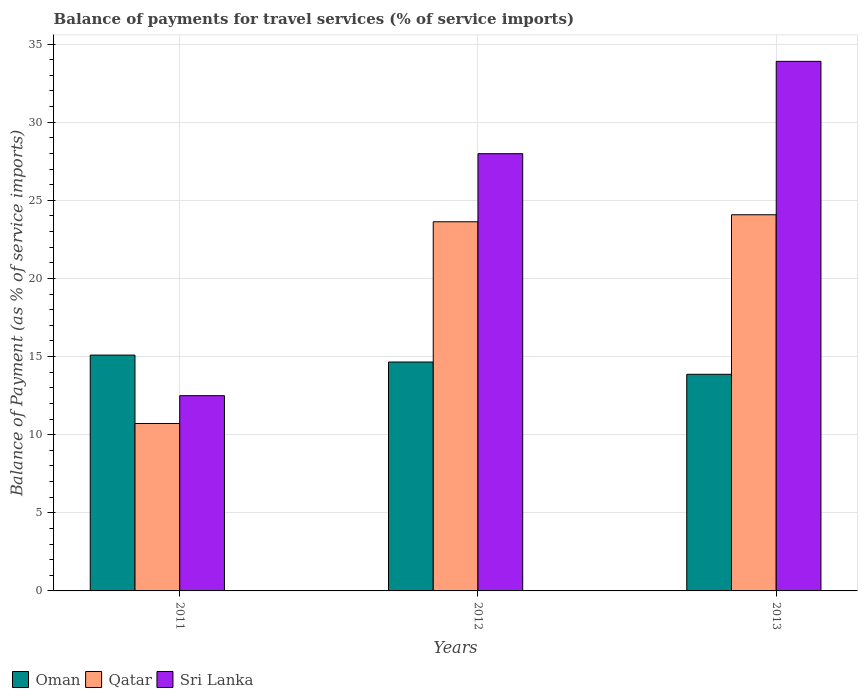How many different coloured bars are there?
Your answer should be compact. 3. How many groups of bars are there?
Your answer should be very brief. 3. Are the number of bars per tick equal to the number of legend labels?
Your answer should be very brief. Yes. Are the number of bars on each tick of the X-axis equal?
Keep it short and to the point. Yes. How many bars are there on the 3rd tick from the right?
Provide a short and direct response. 3. What is the balance of payments for travel services in Sri Lanka in 2011?
Ensure brevity in your answer.  12.5. Across all years, what is the maximum balance of payments for travel services in Oman?
Ensure brevity in your answer.  15.09. Across all years, what is the minimum balance of payments for travel services in Sri Lanka?
Give a very brief answer. 12.5. What is the total balance of payments for travel services in Oman in the graph?
Make the answer very short. 43.61. What is the difference between the balance of payments for travel services in Sri Lanka in 2011 and that in 2012?
Ensure brevity in your answer.  -15.49. What is the difference between the balance of payments for travel services in Oman in 2011 and the balance of payments for travel services in Sri Lanka in 2012?
Make the answer very short. -12.89. What is the average balance of payments for travel services in Sri Lanka per year?
Make the answer very short. 24.79. In the year 2012, what is the difference between the balance of payments for travel services in Sri Lanka and balance of payments for travel services in Qatar?
Your answer should be very brief. 4.36. In how many years, is the balance of payments for travel services in Oman greater than 32 %?
Your response must be concise. 0. What is the ratio of the balance of payments for travel services in Sri Lanka in 2011 to that in 2013?
Offer a very short reply. 0.37. Is the balance of payments for travel services in Qatar in 2011 less than that in 2013?
Give a very brief answer. Yes. Is the difference between the balance of payments for travel services in Sri Lanka in 2011 and 2013 greater than the difference between the balance of payments for travel services in Qatar in 2011 and 2013?
Make the answer very short. No. What is the difference between the highest and the second highest balance of payments for travel services in Sri Lanka?
Provide a succinct answer. 5.91. What is the difference between the highest and the lowest balance of payments for travel services in Oman?
Ensure brevity in your answer.  1.23. In how many years, is the balance of payments for travel services in Oman greater than the average balance of payments for travel services in Oman taken over all years?
Your answer should be very brief. 2. Is the sum of the balance of payments for travel services in Sri Lanka in 2011 and 2013 greater than the maximum balance of payments for travel services in Qatar across all years?
Provide a succinct answer. Yes. What does the 1st bar from the left in 2013 represents?
Ensure brevity in your answer.  Oman. What does the 3rd bar from the right in 2012 represents?
Keep it short and to the point. Oman. How many years are there in the graph?
Your answer should be very brief. 3. What is the difference between two consecutive major ticks on the Y-axis?
Provide a short and direct response. 5. Does the graph contain any zero values?
Provide a short and direct response. No. Does the graph contain grids?
Ensure brevity in your answer.  Yes. How many legend labels are there?
Your answer should be very brief. 3. How are the legend labels stacked?
Ensure brevity in your answer.  Horizontal. What is the title of the graph?
Offer a very short reply. Balance of payments for travel services (% of service imports). What is the label or title of the X-axis?
Provide a short and direct response. Years. What is the label or title of the Y-axis?
Offer a very short reply. Balance of Payment (as % of service imports). What is the Balance of Payment (as % of service imports) in Oman in 2011?
Give a very brief answer. 15.09. What is the Balance of Payment (as % of service imports) of Qatar in 2011?
Offer a terse response. 10.72. What is the Balance of Payment (as % of service imports) in Sri Lanka in 2011?
Offer a terse response. 12.5. What is the Balance of Payment (as % of service imports) in Oman in 2012?
Provide a short and direct response. 14.65. What is the Balance of Payment (as % of service imports) of Qatar in 2012?
Your response must be concise. 23.63. What is the Balance of Payment (as % of service imports) of Sri Lanka in 2012?
Provide a short and direct response. 27.99. What is the Balance of Payment (as % of service imports) in Oman in 2013?
Your answer should be very brief. 13.86. What is the Balance of Payment (as % of service imports) of Qatar in 2013?
Offer a terse response. 24.08. What is the Balance of Payment (as % of service imports) of Sri Lanka in 2013?
Give a very brief answer. 33.9. Across all years, what is the maximum Balance of Payment (as % of service imports) of Oman?
Keep it short and to the point. 15.09. Across all years, what is the maximum Balance of Payment (as % of service imports) in Qatar?
Give a very brief answer. 24.08. Across all years, what is the maximum Balance of Payment (as % of service imports) in Sri Lanka?
Your answer should be very brief. 33.9. Across all years, what is the minimum Balance of Payment (as % of service imports) of Oman?
Provide a short and direct response. 13.86. Across all years, what is the minimum Balance of Payment (as % of service imports) in Qatar?
Provide a succinct answer. 10.72. Across all years, what is the minimum Balance of Payment (as % of service imports) of Sri Lanka?
Keep it short and to the point. 12.5. What is the total Balance of Payment (as % of service imports) in Oman in the graph?
Give a very brief answer. 43.61. What is the total Balance of Payment (as % of service imports) of Qatar in the graph?
Make the answer very short. 58.42. What is the total Balance of Payment (as % of service imports) of Sri Lanka in the graph?
Give a very brief answer. 74.38. What is the difference between the Balance of Payment (as % of service imports) in Oman in 2011 and that in 2012?
Your response must be concise. 0.44. What is the difference between the Balance of Payment (as % of service imports) of Qatar in 2011 and that in 2012?
Ensure brevity in your answer.  -12.91. What is the difference between the Balance of Payment (as % of service imports) of Sri Lanka in 2011 and that in 2012?
Keep it short and to the point. -15.49. What is the difference between the Balance of Payment (as % of service imports) of Oman in 2011 and that in 2013?
Give a very brief answer. 1.23. What is the difference between the Balance of Payment (as % of service imports) in Qatar in 2011 and that in 2013?
Ensure brevity in your answer.  -13.36. What is the difference between the Balance of Payment (as % of service imports) of Sri Lanka in 2011 and that in 2013?
Offer a very short reply. -21.4. What is the difference between the Balance of Payment (as % of service imports) of Oman in 2012 and that in 2013?
Provide a succinct answer. 0.79. What is the difference between the Balance of Payment (as % of service imports) of Qatar in 2012 and that in 2013?
Your response must be concise. -0.45. What is the difference between the Balance of Payment (as % of service imports) in Sri Lanka in 2012 and that in 2013?
Offer a terse response. -5.91. What is the difference between the Balance of Payment (as % of service imports) of Oman in 2011 and the Balance of Payment (as % of service imports) of Qatar in 2012?
Your answer should be compact. -8.53. What is the difference between the Balance of Payment (as % of service imports) in Oman in 2011 and the Balance of Payment (as % of service imports) in Sri Lanka in 2012?
Provide a short and direct response. -12.89. What is the difference between the Balance of Payment (as % of service imports) of Qatar in 2011 and the Balance of Payment (as % of service imports) of Sri Lanka in 2012?
Your answer should be compact. -17.27. What is the difference between the Balance of Payment (as % of service imports) in Oman in 2011 and the Balance of Payment (as % of service imports) in Qatar in 2013?
Give a very brief answer. -8.98. What is the difference between the Balance of Payment (as % of service imports) in Oman in 2011 and the Balance of Payment (as % of service imports) in Sri Lanka in 2013?
Offer a very short reply. -18.8. What is the difference between the Balance of Payment (as % of service imports) of Qatar in 2011 and the Balance of Payment (as % of service imports) of Sri Lanka in 2013?
Keep it short and to the point. -23.18. What is the difference between the Balance of Payment (as % of service imports) in Oman in 2012 and the Balance of Payment (as % of service imports) in Qatar in 2013?
Make the answer very short. -9.43. What is the difference between the Balance of Payment (as % of service imports) of Oman in 2012 and the Balance of Payment (as % of service imports) of Sri Lanka in 2013?
Offer a terse response. -19.24. What is the difference between the Balance of Payment (as % of service imports) in Qatar in 2012 and the Balance of Payment (as % of service imports) in Sri Lanka in 2013?
Your answer should be compact. -10.27. What is the average Balance of Payment (as % of service imports) of Oman per year?
Offer a terse response. 14.54. What is the average Balance of Payment (as % of service imports) in Qatar per year?
Provide a succinct answer. 19.47. What is the average Balance of Payment (as % of service imports) of Sri Lanka per year?
Offer a very short reply. 24.79. In the year 2011, what is the difference between the Balance of Payment (as % of service imports) of Oman and Balance of Payment (as % of service imports) of Qatar?
Give a very brief answer. 4.38. In the year 2011, what is the difference between the Balance of Payment (as % of service imports) of Oman and Balance of Payment (as % of service imports) of Sri Lanka?
Provide a short and direct response. 2.6. In the year 2011, what is the difference between the Balance of Payment (as % of service imports) in Qatar and Balance of Payment (as % of service imports) in Sri Lanka?
Your answer should be very brief. -1.78. In the year 2012, what is the difference between the Balance of Payment (as % of service imports) in Oman and Balance of Payment (as % of service imports) in Qatar?
Your answer should be very brief. -8.98. In the year 2012, what is the difference between the Balance of Payment (as % of service imports) in Oman and Balance of Payment (as % of service imports) in Sri Lanka?
Your answer should be very brief. -13.34. In the year 2012, what is the difference between the Balance of Payment (as % of service imports) of Qatar and Balance of Payment (as % of service imports) of Sri Lanka?
Your answer should be very brief. -4.36. In the year 2013, what is the difference between the Balance of Payment (as % of service imports) of Oman and Balance of Payment (as % of service imports) of Qatar?
Offer a very short reply. -10.21. In the year 2013, what is the difference between the Balance of Payment (as % of service imports) in Oman and Balance of Payment (as % of service imports) in Sri Lanka?
Your answer should be compact. -20.03. In the year 2013, what is the difference between the Balance of Payment (as % of service imports) of Qatar and Balance of Payment (as % of service imports) of Sri Lanka?
Provide a short and direct response. -9.82. What is the ratio of the Balance of Payment (as % of service imports) of Oman in 2011 to that in 2012?
Your response must be concise. 1.03. What is the ratio of the Balance of Payment (as % of service imports) of Qatar in 2011 to that in 2012?
Your answer should be compact. 0.45. What is the ratio of the Balance of Payment (as % of service imports) of Sri Lanka in 2011 to that in 2012?
Provide a short and direct response. 0.45. What is the ratio of the Balance of Payment (as % of service imports) of Oman in 2011 to that in 2013?
Keep it short and to the point. 1.09. What is the ratio of the Balance of Payment (as % of service imports) of Qatar in 2011 to that in 2013?
Your response must be concise. 0.45. What is the ratio of the Balance of Payment (as % of service imports) in Sri Lanka in 2011 to that in 2013?
Your answer should be compact. 0.37. What is the ratio of the Balance of Payment (as % of service imports) of Oman in 2012 to that in 2013?
Provide a short and direct response. 1.06. What is the ratio of the Balance of Payment (as % of service imports) in Qatar in 2012 to that in 2013?
Provide a short and direct response. 0.98. What is the ratio of the Balance of Payment (as % of service imports) of Sri Lanka in 2012 to that in 2013?
Your answer should be very brief. 0.83. What is the difference between the highest and the second highest Balance of Payment (as % of service imports) in Oman?
Provide a short and direct response. 0.44. What is the difference between the highest and the second highest Balance of Payment (as % of service imports) of Qatar?
Offer a terse response. 0.45. What is the difference between the highest and the second highest Balance of Payment (as % of service imports) in Sri Lanka?
Make the answer very short. 5.91. What is the difference between the highest and the lowest Balance of Payment (as % of service imports) of Oman?
Offer a terse response. 1.23. What is the difference between the highest and the lowest Balance of Payment (as % of service imports) of Qatar?
Offer a terse response. 13.36. What is the difference between the highest and the lowest Balance of Payment (as % of service imports) in Sri Lanka?
Provide a short and direct response. 21.4. 